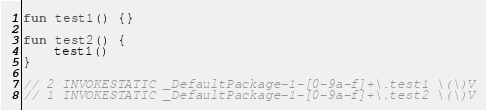<code> <loc_0><loc_0><loc_500><loc_500><_Kotlin_>fun test1() {}

fun test2() {
    test1()
}

// 2 INVOKESTATIC _DefaultPackage-1-[0-9a-f]+\.test1 \(\)V
// 1 INVOKESTATIC _DefaultPackage-1-[0-9a-f]+\.test2 \(\)V
</code> 